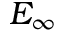<formula> <loc_0><loc_0><loc_500><loc_500>E _ { \infty }</formula> 